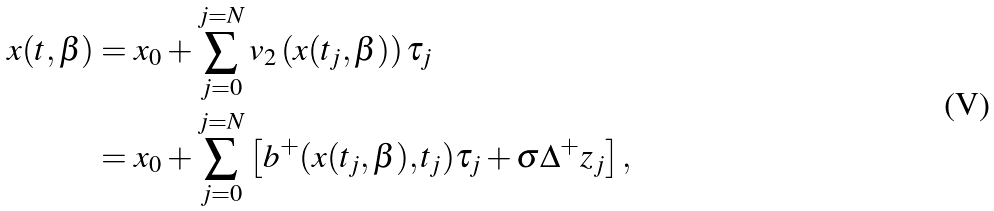<formula> <loc_0><loc_0><loc_500><loc_500>x ( t , \beta ) & = x _ { 0 } + \sum _ { j = 0 } ^ { j = N } v _ { 2 } \left ( x ( t _ { j } , \beta ) \right ) \tau _ { j } \\ & = x _ { 0 } + \sum _ { j = 0 } ^ { j = N } \left [ b ^ { + } ( x ( t _ { j } , \beta ) , t _ { j } ) \tau _ { j } + \sigma \Delta ^ { + } z _ { j } \right ] ,</formula> 